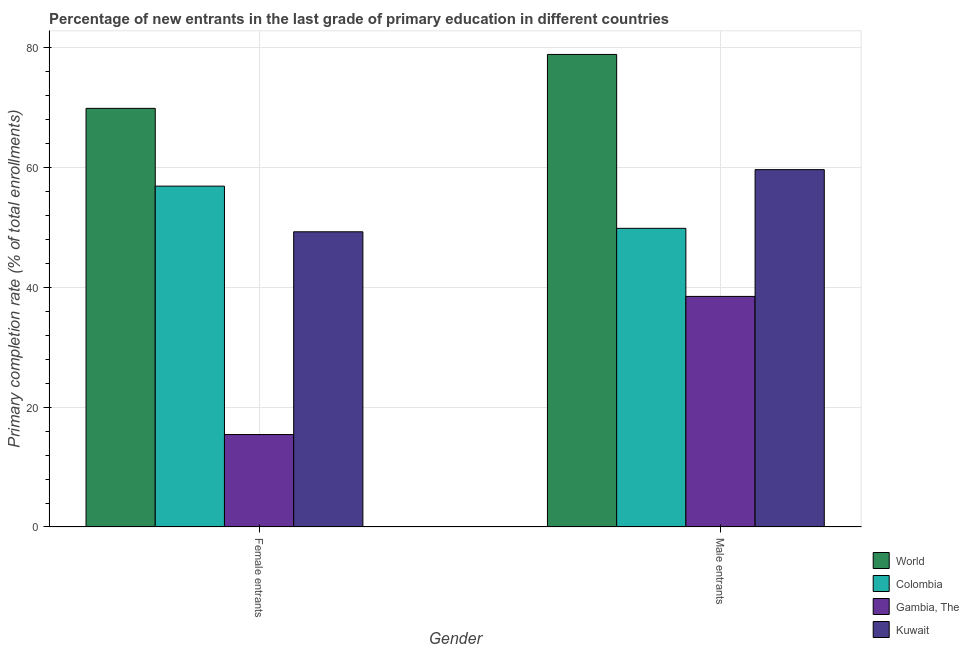How many different coloured bars are there?
Your response must be concise. 4. What is the label of the 2nd group of bars from the left?
Provide a short and direct response. Male entrants. What is the primary completion rate of female entrants in Kuwait?
Provide a short and direct response. 49.25. Across all countries, what is the maximum primary completion rate of female entrants?
Your answer should be very brief. 69.84. Across all countries, what is the minimum primary completion rate of female entrants?
Make the answer very short. 15.43. In which country was the primary completion rate of male entrants minimum?
Provide a succinct answer. Gambia, The. What is the total primary completion rate of female entrants in the graph?
Provide a short and direct response. 191.39. What is the difference between the primary completion rate of female entrants in Kuwait and that in Gambia, The?
Ensure brevity in your answer.  33.82. What is the difference between the primary completion rate of female entrants in World and the primary completion rate of male entrants in Gambia, The?
Your response must be concise. 31.37. What is the average primary completion rate of female entrants per country?
Your response must be concise. 47.85. What is the difference between the primary completion rate of male entrants and primary completion rate of female entrants in Gambia, The?
Make the answer very short. 23.04. In how many countries, is the primary completion rate of female entrants greater than 60 %?
Make the answer very short. 1. What is the ratio of the primary completion rate of male entrants in Kuwait to that in World?
Offer a terse response. 0.76. In how many countries, is the primary completion rate of male entrants greater than the average primary completion rate of male entrants taken over all countries?
Offer a terse response. 2. What does the 2nd bar from the left in Male entrants represents?
Your response must be concise. Colombia. Are all the bars in the graph horizontal?
Offer a very short reply. No. How many countries are there in the graph?
Provide a succinct answer. 4. Does the graph contain any zero values?
Provide a succinct answer. No. Does the graph contain grids?
Give a very brief answer. Yes. How are the legend labels stacked?
Keep it short and to the point. Vertical. What is the title of the graph?
Keep it short and to the point. Percentage of new entrants in the last grade of primary education in different countries. Does "Djibouti" appear as one of the legend labels in the graph?
Ensure brevity in your answer.  No. What is the label or title of the Y-axis?
Your response must be concise. Primary completion rate (% of total enrollments). What is the Primary completion rate (% of total enrollments) of World in Female entrants?
Make the answer very short. 69.84. What is the Primary completion rate (% of total enrollments) in Colombia in Female entrants?
Ensure brevity in your answer.  56.87. What is the Primary completion rate (% of total enrollments) of Gambia, The in Female entrants?
Provide a short and direct response. 15.43. What is the Primary completion rate (% of total enrollments) of Kuwait in Female entrants?
Provide a short and direct response. 49.25. What is the Primary completion rate (% of total enrollments) of World in Male entrants?
Ensure brevity in your answer.  78.84. What is the Primary completion rate (% of total enrollments) of Colombia in Male entrants?
Your answer should be compact. 49.83. What is the Primary completion rate (% of total enrollments) in Gambia, The in Male entrants?
Offer a terse response. 38.47. What is the Primary completion rate (% of total enrollments) in Kuwait in Male entrants?
Offer a very short reply. 59.62. Across all Gender, what is the maximum Primary completion rate (% of total enrollments) in World?
Provide a short and direct response. 78.84. Across all Gender, what is the maximum Primary completion rate (% of total enrollments) of Colombia?
Provide a succinct answer. 56.87. Across all Gender, what is the maximum Primary completion rate (% of total enrollments) in Gambia, The?
Ensure brevity in your answer.  38.47. Across all Gender, what is the maximum Primary completion rate (% of total enrollments) of Kuwait?
Offer a terse response. 59.62. Across all Gender, what is the minimum Primary completion rate (% of total enrollments) of World?
Offer a very short reply. 69.84. Across all Gender, what is the minimum Primary completion rate (% of total enrollments) of Colombia?
Provide a succinct answer. 49.83. Across all Gender, what is the minimum Primary completion rate (% of total enrollments) in Gambia, The?
Your answer should be compact. 15.43. Across all Gender, what is the minimum Primary completion rate (% of total enrollments) of Kuwait?
Offer a very short reply. 49.25. What is the total Primary completion rate (% of total enrollments) in World in the graph?
Offer a very short reply. 148.68. What is the total Primary completion rate (% of total enrollments) in Colombia in the graph?
Give a very brief answer. 106.7. What is the total Primary completion rate (% of total enrollments) in Gambia, The in the graph?
Provide a succinct answer. 53.9. What is the total Primary completion rate (% of total enrollments) of Kuwait in the graph?
Provide a succinct answer. 108.87. What is the difference between the Primary completion rate (% of total enrollments) of World in Female entrants and that in Male entrants?
Keep it short and to the point. -8.99. What is the difference between the Primary completion rate (% of total enrollments) of Colombia in Female entrants and that in Male entrants?
Your answer should be compact. 7.04. What is the difference between the Primary completion rate (% of total enrollments) of Gambia, The in Female entrants and that in Male entrants?
Provide a short and direct response. -23.04. What is the difference between the Primary completion rate (% of total enrollments) of Kuwait in Female entrants and that in Male entrants?
Your answer should be compact. -10.37. What is the difference between the Primary completion rate (% of total enrollments) in World in Female entrants and the Primary completion rate (% of total enrollments) in Colombia in Male entrants?
Give a very brief answer. 20.01. What is the difference between the Primary completion rate (% of total enrollments) in World in Female entrants and the Primary completion rate (% of total enrollments) in Gambia, The in Male entrants?
Your answer should be very brief. 31.37. What is the difference between the Primary completion rate (% of total enrollments) of World in Female entrants and the Primary completion rate (% of total enrollments) of Kuwait in Male entrants?
Provide a short and direct response. 10.22. What is the difference between the Primary completion rate (% of total enrollments) in Colombia in Female entrants and the Primary completion rate (% of total enrollments) in Gambia, The in Male entrants?
Keep it short and to the point. 18.4. What is the difference between the Primary completion rate (% of total enrollments) of Colombia in Female entrants and the Primary completion rate (% of total enrollments) of Kuwait in Male entrants?
Offer a terse response. -2.75. What is the difference between the Primary completion rate (% of total enrollments) in Gambia, The in Female entrants and the Primary completion rate (% of total enrollments) in Kuwait in Male entrants?
Provide a short and direct response. -44.19. What is the average Primary completion rate (% of total enrollments) in World per Gender?
Ensure brevity in your answer.  74.34. What is the average Primary completion rate (% of total enrollments) of Colombia per Gender?
Your answer should be compact. 53.35. What is the average Primary completion rate (% of total enrollments) of Gambia, The per Gender?
Offer a very short reply. 26.95. What is the average Primary completion rate (% of total enrollments) of Kuwait per Gender?
Ensure brevity in your answer.  54.44. What is the difference between the Primary completion rate (% of total enrollments) in World and Primary completion rate (% of total enrollments) in Colombia in Female entrants?
Your answer should be very brief. 12.98. What is the difference between the Primary completion rate (% of total enrollments) of World and Primary completion rate (% of total enrollments) of Gambia, The in Female entrants?
Give a very brief answer. 54.42. What is the difference between the Primary completion rate (% of total enrollments) of World and Primary completion rate (% of total enrollments) of Kuwait in Female entrants?
Offer a terse response. 20.59. What is the difference between the Primary completion rate (% of total enrollments) of Colombia and Primary completion rate (% of total enrollments) of Gambia, The in Female entrants?
Offer a terse response. 41.44. What is the difference between the Primary completion rate (% of total enrollments) of Colombia and Primary completion rate (% of total enrollments) of Kuwait in Female entrants?
Offer a very short reply. 7.62. What is the difference between the Primary completion rate (% of total enrollments) of Gambia, The and Primary completion rate (% of total enrollments) of Kuwait in Female entrants?
Provide a short and direct response. -33.82. What is the difference between the Primary completion rate (% of total enrollments) of World and Primary completion rate (% of total enrollments) of Colombia in Male entrants?
Offer a terse response. 29.01. What is the difference between the Primary completion rate (% of total enrollments) of World and Primary completion rate (% of total enrollments) of Gambia, The in Male entrants?
Your answer should be very brief. 40.37. What is the difference between the Primary completion rate (% of total enrollments) in World and Primary completion rate (% of total enrollments) in Kuwait in Male entrants?
Your answer should be compact. 19.22. What is the difference between the Primary completion rate (% of total enrollments) of Colombia and Primary completion rate (% of total enrollments) of Gambia, The in Male entrants?
Your response must be concise. 11.36. What is the difference between the Primary completion rate (% of total enrollments) in Colombia and Primary completion rate (% of total enrollments) in Kuwait in Male entrants?
Your answer should be compact. -9.79. What is the difference between the Primary completion rate (% of total enrollments) in Gambia, The and Primary completion rate (% of total enrollments) in Kuwait in Male entrants?
Offer a terse response. -21.15. What is the ratio of the Primary completion rate (% of total enrollments) in World in Female entrants to that in Male entrants?
Provide a short and direct response. 0.89. What is the ratio of the Primary completion rate (% of total enrollments) of Colombia in Female entrants to that in Male entrants?
Your answer should be very brief. 1.14. What is the ratio of the Primary completion rate (% of total enrollments) in Gambia, The in Female entrants to that in Male entrants?
Your response must be concise. 0.4. What is the ratio of the Primary completion rate (% of total enrollments) in Kuwait in Female entrants to that in Male entrants?
Offer a terse response. 0.83. What is the difference between the highest and the second highest Primary completion rate (% of total enrollments) of World?
Provide a short and direct response. 8.99. What is the difference between the highest and the second highest Primary completion rate (% of total enrollments) in Colombia?
Offer a terse response. 7.04. What is the difference between the highest and the second highest Primary completion rate (% of total enrollments) of Gambia, The?
Ensure brevity in your answer.  23.04. What is the difference between the highest and the second highest Primary completion rate (% of total enrollments) of Kuwait?
Offer a very short reply. 10.37. What is the difference between the highest and the lowest Primary completion rate (% of total enrollments) of World?
Ensure brevity in your answer.  8.99. What is the difference between the highest and the lowest Primary completion rate (% of total enrollments) in Colombia?
Your answer should be compact. 7.04. What is the difference between the highest and the lowest Primary completion rate (% of total enrollments) of Gambia, The?
Your answer should be compact. 23.04. What is the difference between the highest and the lowest Primary completion rate (% of total enrollments) in Kuwait?
Offer a very short reply. 10.37. 